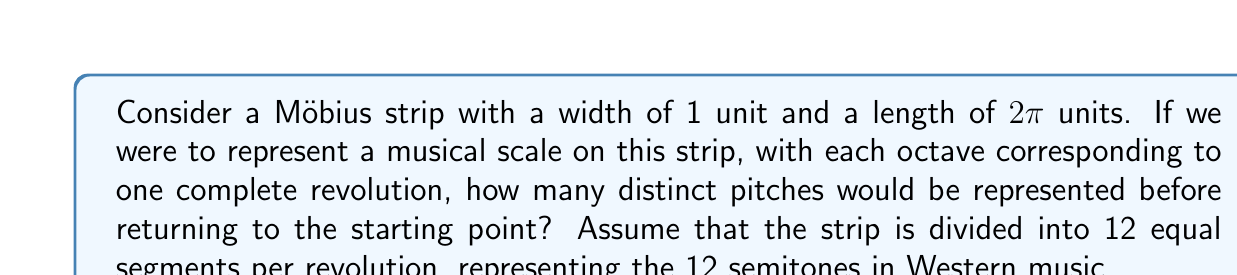Show me your answer to this math problem. Let's approach this step-by-step:

1) First, we need to understand the properties of a Möbius strip:
   - It has only one side and one edge
   - It is non-orientable
   - A line drawn down the center will return to its starting point after two revolutions

2) In our case, we're representing a musical scale on the strip:
   - One revolution represents one octave
   - Each octave is divided into 12 semitones

3) Let's visualize the path of a pitch as it travels along the strip:
   - After one revolution, it will be on the opposite side of the strip
   - It needs to complete another revolution to return to the starting point

4) This means that to return to the exact starting point, we need to complete two full revolutions.

5) Calculate the number of distinct pitches:
   - In one revolution, we have 12 semitones
   - We need two revolutions to return to the start
   - Total number of distinct pitches = $12 \times 2 = 24$

6) Musically, this represents two octaves before repeating.

7) We can represent this mathematically as:

   $$N = n \times r$$

   Where:
   $N$ is the total number of distinct pitches
   $n$ is the number of divisions per revolution (semitones per octave)
   $r$ is the number of revolutions to return to the start

8) In our case:
   $$N = 12 \times 2 = 24$$

This property of the Möbius strip could be used to visualize the cyclical nature of musical scales across multiple octaves, demonstrating how pitches relate to each other in a continuous, looping manner.
Answer: 24 distinct pitches 